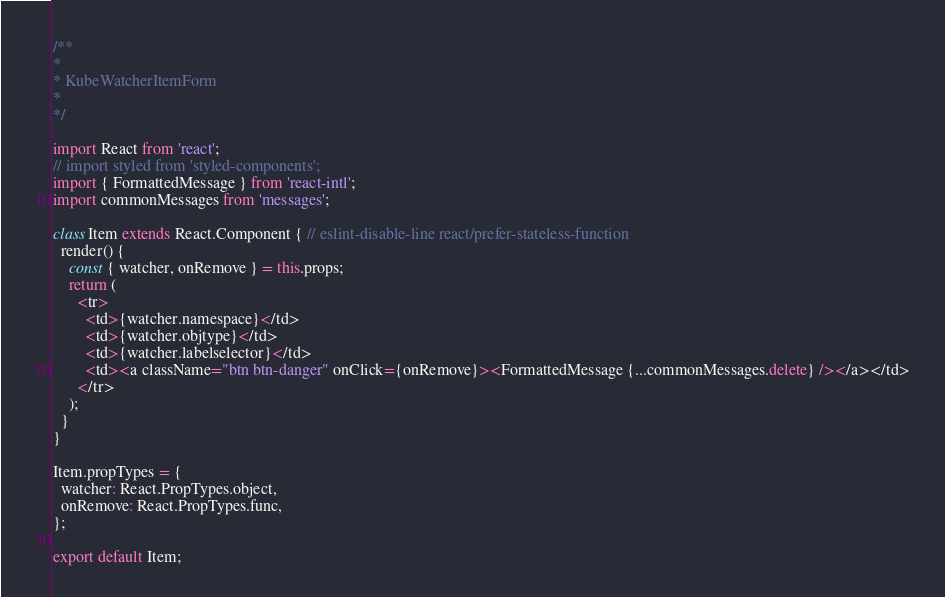<code> <loc_0><loc_0><loc_500><loc_500><_JavaScript_>/**
*
* KubeWatcherItemForm
*
*/

import React from 'react';
// import styled from 'styled-components';
import { FormattedMessage } from 'react-intl';
import commonMessages from 'messages';

class Item extends React.Component { // eslint-disable-line react/prefer-stateless-function
  render() {
    const { watcher, onRemove } = this.props;
    return (
      <tr>
        <td>{watcher.namespace}</td>
        <td>{watcher.objtype}</td>
        <td>{watcher.labelselector}</td>
        <td><a className="btn btn-danger" onClick={onRemove}><FormattedMessage {...commonMessages.delete} /></a></td>
      </tr>
    );
  }
}

Item.propTypes = {
  watcher: React.PropTypes.object,
  onRemove: React.PropTypes.func,
};

export default Item;
</code> 